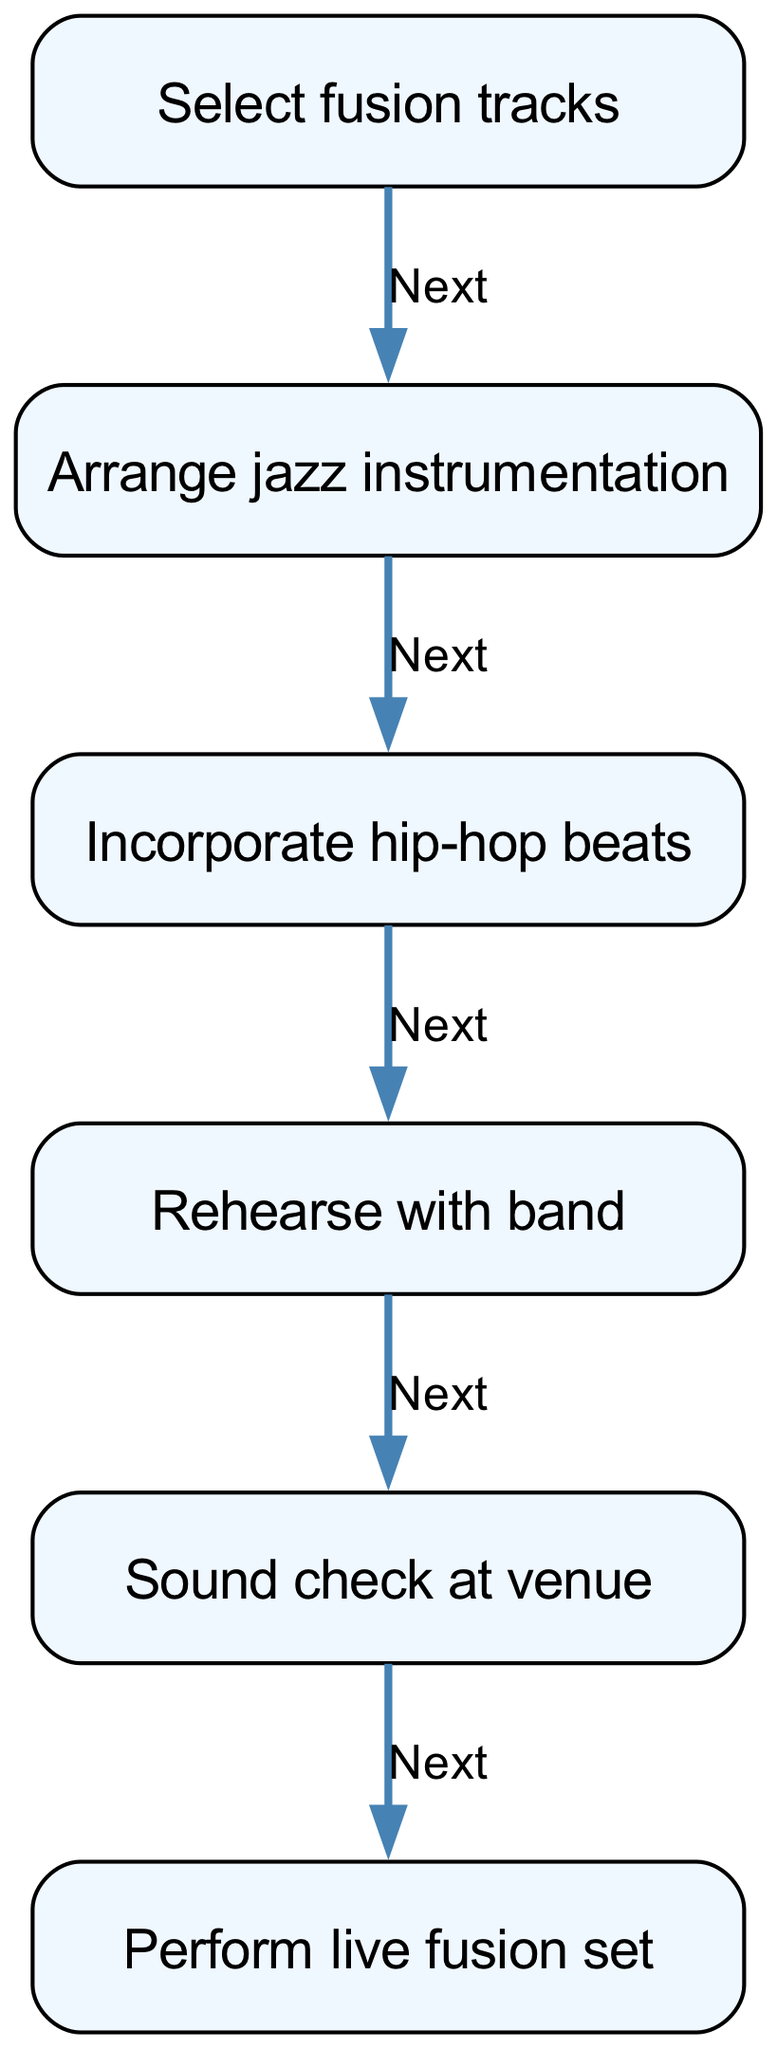What is the first step in the performance plan? The first step in the diagram is labeled as "Select fusion tracks," indicating it is the starting point of the flow for planning the performance.
Answer: Select fusion tracks How many nodes are in the diagram? The diagram contains a total of six nodes, each representing a distinct step in the planning and execution of the live performance, from selecting tracks to performing the set.
Answer: Six What step comes after "Rehearse with band"? Referring to the flow of the diagram, the step that follows "Rehearse with band" is "Sound check at venue." This indicates the next action taken in preparation for the live performance.
Answer: Sound check at venue What are the two primary components included in the preparation stages? Throughout the preparation stages of the performance plan, the main components are "Arrange jazz instrumentation" and "Incorporate hip-hop beats," both of which are essential for creating the fusion music style.
Answer: Arrange jazz instrumentation and Incorporate hip-hop beats Which step directly leads to the live performance? In the flow chart, the step labeled "Perform live fusion set" is the final action that comes after all the preparatory steps, thus directly leading to the live performance.
Answer: Perform live fusion set What is the last action in the performance flow? According to the diagram, the last action listed is "Perform live fusion set," indicating it is the ultimate goal of the entire process outlined in the flow.
Answer: Perform live fusion set 